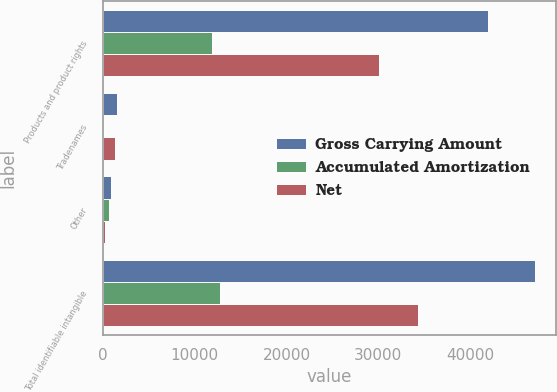<chart> <loc_0><loc_0><loc_500><loc_500><stacked_bar_chart><ecel><fcel>Products and product rights<fcel>Tradenames<fcel>Other<fcel>Total identifiable intangible<nl><fcel>Gross Carrying Amount<fcel>41937<fcel>1523<fcel>895<fcel>47026<nl><fcel>Accumulated Amortization<fcel>11872<fcel>170<fcel>682<fcel>12724<nl><fcel>Net<fcel>30065<fcel>1353<fcel>213<fcel>34302<nl></chart> 